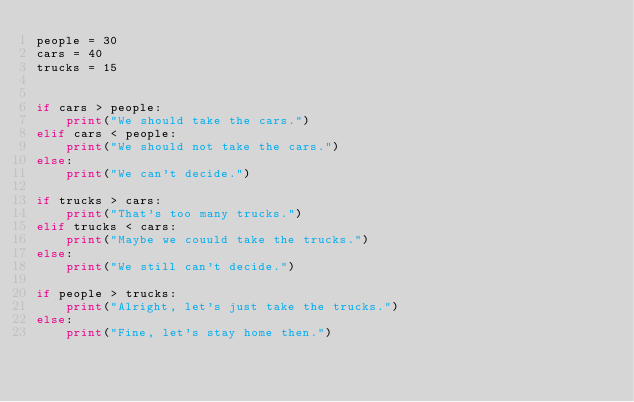Convert code to text. <code><loc_0><loc_0><loc_500><loc_500><_Python_>people = 30
cars = 40
trucks = 15


if cars > people:
	print("We should take the cars.")
elif cars < people: 
    print("We should not take the cars.")
else:
    print("We can't decide.")

if trucks > cars:
    print("That's too many trucks.")
elif trucks < cars:
    print("Maybe we couuld take the trucks.")
else: 
    print("We still can't decide.")

if people > trucks:
    print("Alright, let's just take the trucks.")
else:
    print("Fine, let's stay home then.")</code> 